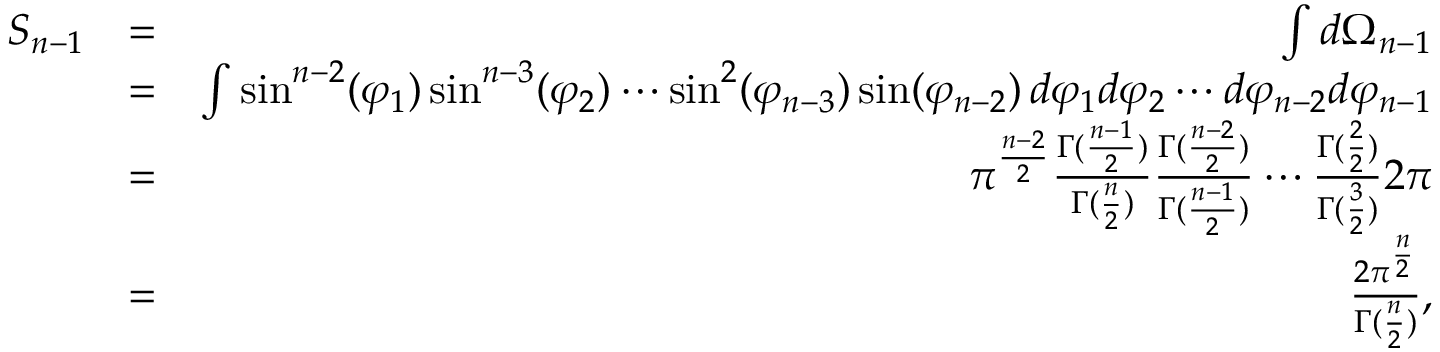Convert formula to latex. <formula><loc_0><loc_0><loc_500><loc_500>\begin{array} { r l r } { S _ { n - 1 } } & { = } & { \int d \Omega _ { n - 1 } } \\ & { = } & { \int \sin ^ { n - 2 } ( \varphi _ { 1 } ) \sin ^ { n - 3 } ( \varphi _ { 2 } ) \cdots \sin ^ { 2 } ( \varphi _ { n - 3 } ) \sin ( \varphi _ { n - 2 } ) \, d \varphi _ { 1 } d \varphi _ { 2 } \cdots d \varphi _ { n - 2 } d \varphi _ { n - 1 } } \\ & { = } & { \pi ^ { \frac { n - 2 } { 2 } } \frac { \Gamma ( \frac { n - 1 } { 2 } ) } { \Gamma ( \frac { n } { 2 } ) } \frac { \Gamma ( \frac { n - 2 } { 2 } ) } { \Gamma ( \frac { n - 1 } { 2 } ) } \cdots \frac { \Gamma ( \frac { 2 } { 2 } ) } { \Gamma ( \frac { 3 } { 2 } ) } 2 \pi } \\ & { = } & { \frac { 2 \pi ^ { \frac { n } { 2 } } } { \Gamma ( \frac { n } { 2 } ) } , } \end{array}</formula> 